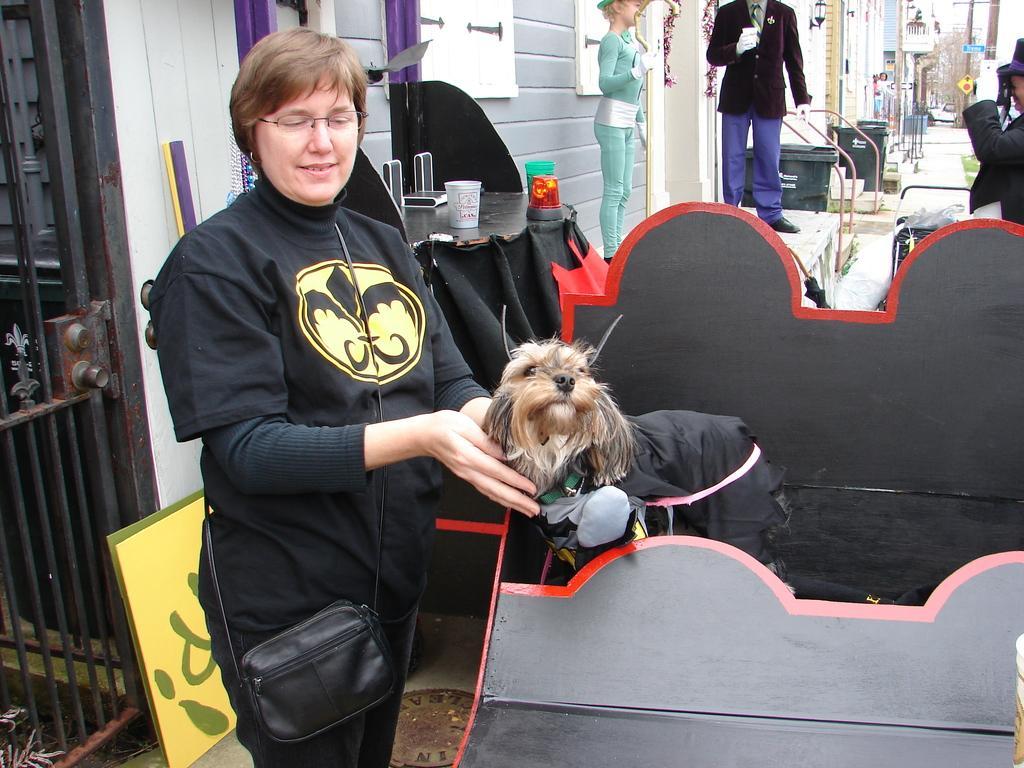In one or two sentences, can you explain what this image depicts? In this picture we can see a woman standing and smiling, dog, glasses, mannequins,wall, buildings and in the background we can see trees. 